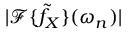Convert formula to latex. <formula><loc_0><loc_0><loc_500><loc_500>| \mathcal { F } \{ \tilde { f } _ { X } \} ( \omega _ { n } ) |</formula> 